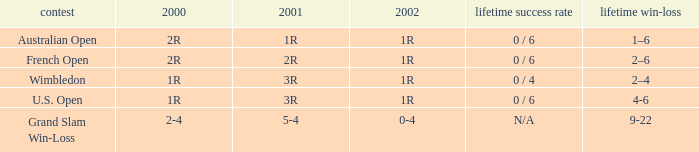Which career win-loss record has a 1r in 2002, a 2r in 2000 and a 2r in 2001? 2–6. 